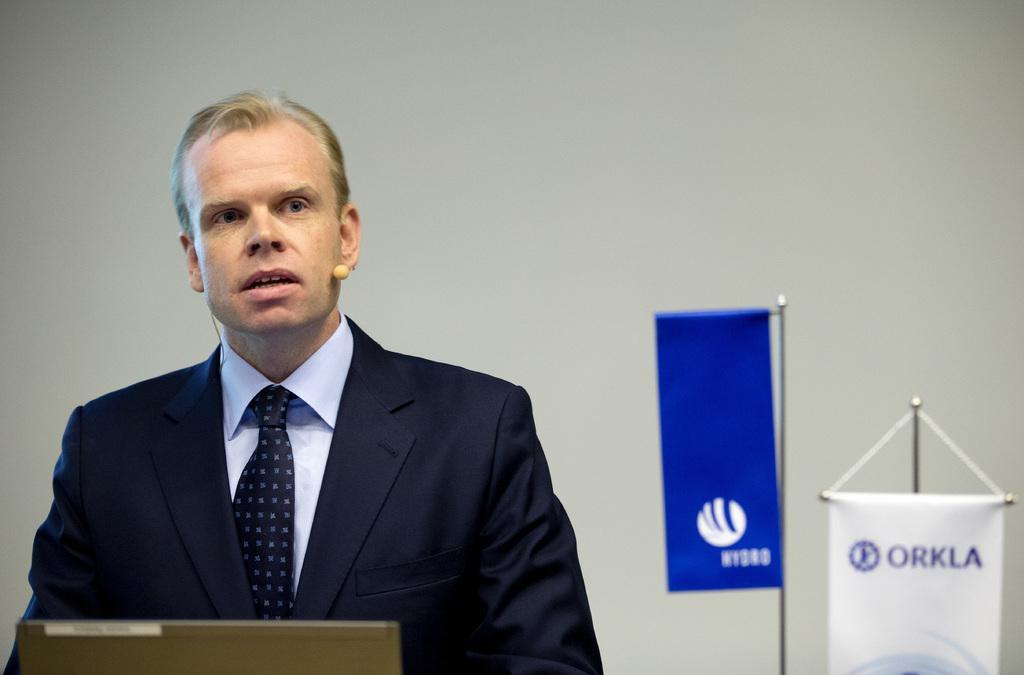In one or two sentences, can you explain what this image depicts? In this image we can see a person wearing suit. In the background of the image there is wall. There are two banners with some text on them. 